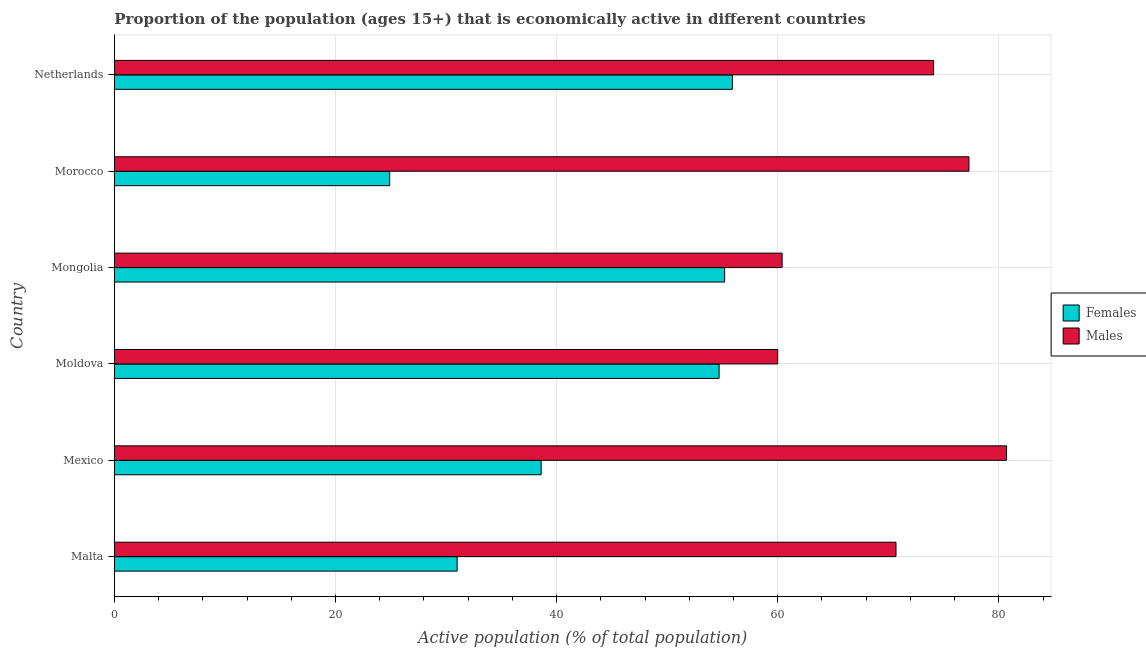How many groups of bars are there?
Your response must be concise. 6. Are the number of bars on each tick of the Y-axis equal?
Offer a very short reply. Yes. What is the label of the 2nd group of bars from the top?
Keep it short and to the point. Morocco. Across all countries, what is the maximum percentage of economically active female population?
Your response must be concise. 55.9. Across all countries, what is the minimum percentage of economically active male population?
Your answer should be compact. 60. In which country was the percentage of economically active female population minimum?
Your answer should be compact. Morocco. What is the total percentage of economically active male population in the graph?
Provide a short and direct response. 423.2. What is the difference between the percentage of economically active male population in Mongolia and that in Morocco?
Your answer should be compact. -16.9. What is the difference between the percentage of economically active male population in Mongolia and the percentage of economically active female population in Mexico?
Make the answer very short. 21.8. What is the average percentage of economically active female population per country?
Provide a short and direct response. 43.38. What is the ratio of the percentage of economically active male population in Mexico to that in Moldova?
Make the answer very short. 1.34. What is the difference between the highest and the lowest percentage of economically active male population?
Provide a succinct answer. 20.7. In how many countries, is the percentage of economically active male population greater than the average percentage of economically active male population taken over all countries?
Provide a succinct answer. 4. What does the 2nd bar from the top in Malta represents?
Give a very brief answer. Females. What does the 2nd bar from the bottom in Mongolia represents?
Give a very brief answer. Males. Are the values on the major ticks of X-axis written in scientific E-notation?
Offer a terse response. No. Does the graph contain any zero values?
Make the answer very short. No. How are the legend labels stacked?
Ensure brevity in your answer.  Vertical. What is the title of the graph?
Offer a terse response. Proportion of the population (ages 15+) that is economically active in different countries. What is the label or title of the X-axis?
Provide a short and direct response. Active population (% of total population). What is the label or title of the Y-axis?
Offer a terse response. Country. What is the Active population (% of total population) in Females in Malta?
Offer a very short reply. 31. What is the Active population (% of total population) in Males in Malta?
Make the answer very short. 70.7. What is the Active population (% of total population) in Females in Mexico?
Offer a very short reply. 38.6. What is the Active population (% of total population) in Males in Mexico?
Provide a succinct answer. 80.7. What is the Active population (% of total population) in Females in Moldova?
Provide a short and direct response. 54.7. What is the Active population (% of total population) of Males in Moldova?
Your answer should be compact. 60. What is the Active population (% of total population) of Females in Mongolia?
Offer a very short reply. 55.2. What is the Active population (% of total population) of Males in Mongolia?
Provide a succinct answer. 60.4. What is the Active population (% of total population) of Females in Morocco?
Offer a terse response. 24.9. What is the Active population (% of total population) in Males in Morocco?
Your answer should be very brief. 77.3. What is the Active population (% of total population) in Females in Netherlands?
Offer a very short reply. 55.9. What is the Active population (% of total population) of Males in Netherlands?
Your answer should be compact. 74.1. Across all countries, what is the maximum Active population (% of total population) in Females?
Give a very brief answer. 55.9. Across all countries, what is the maximum Active population (% of total population) of Males?
Your answer should be compact. 80.7. Across all countries, what is the minimum Active population (% of total population) of Females?
Keep it short and to the point. 24.9. What is the total Active population (% of total population) in Females in the graph?
Give a very brief answer. 260.3. What is the total Active population (% of total population) of Males in the graph?
Give a very brief answer. 423.2. What is the difference between the Active population (% of total population) in Females in Malta and that in Moldova?
Make the answer very short. -23.7. What is the difference between the Active population (% of total population) in Males in Malta and that in Moldova?
Your answer should be very brief. 10.7. What is the difference between the Active population (% of total population) in Females in Malta and that in Mongolia?
Make the answer very short. -24.2. What is the difference between the Active population (% of total population) of Males in Malta and that in Mongolia?
Provide a succinct answer. 10.3. What is the difference between the Active population (% of total population) in Females in Malta and that in Netherlands?
Offer a very short reply. -24.9. What is the difference between the Active population (% of total population) of Males in Malta and that in Netherlands?
Offer a terse response. -3.4. What is the difference between the Active population (% of total population) in Females in Mexico and that in Moldova?
Keep it short and to the point. -16.1. What is the difference between the Active population (% of total population) of Males in Mexico and that in Moldova?
Your answer should be compact. 20.7. What is the difference between the Active population (% of total population) of Females in Mexico and that in Mongolia?
Make the answer very short. -16.6. What is the difference between the Active population (% of total population) of Males in Mexico and that in Mongolia?
Offer a very short reply. 20.3. What is the difference between the Active population (% of total population) in Females in Mexico and that in Netherlands?
Make the answer very short. -17.3. What is the difference between the Active population (% of total population) of Males in Mexico and that in Netherlands?
Offer a terse response. 6.6. What is the difference between the Active population (% of total population) in Females in Moldova and that in Morocco?
Ensure brevity in your answer.  29.8. What is the difference between the Active population (% of total population) of Males in Moldova and that in Morocco?
Give a very brief answer. -17.3. What is the difference between the Active population (% of total population) in Males in Moldova and that in Netherlands?
Make the answer very short. -14.1. What is the difference between the Active population (% of total population) of Females in Mongolia and that in Morocco?
Ensure brevity in your answer.  30.3. What is the difference between the Active population (% of total population) in Males in Mongolia and that in Morocco?
Offer a very short reply. -16.9. What is the difference between the Active population (% of total population) of Males in Mongolia and that in Netherlands?
Provide a succinct answer. -13.7. What is the difference between the Active population (% of total population) in Females in Morocco and that in Netherlands?
Provide a succinct answer. -31. What is the difference between the Active population (% of total population) in Females in Malta and the Active population (% of total population) in Males in Mexico?
Ensure brevity in your answer.  -49.7. What is the difference between the Active population (% of total population) in Females in Malta and the Active population (% of total population) in Males in Mongolia?
Provide a short and direct response. -29.4. What is the difference between the Active population (% of total population) in Females in Malta and the Active population (% of total population) in Males in Morocco?
Make the answer very short. -46.3. What is the difference between the Active population (% of total population) of Females in Malta and the Active population (% of total population) of Males in Netherlands?
Make the answer very short. -43.1. What is the difference between the Active population (% of total population) in Females in Mexico and the Active population (% of total population) in Males in Moldova?
Provide a short and direct response. -21.4. What is the difference between the Active population (% of total population) of Females in Mexico and the Active population (% of total population) of Males in Mongolia?
Ensure brevity in your answer.  -21.8. What is the difference between the Active population (% of total population) of Females in Mexico and the Active population (% of total population) of Males in Morocco?
Offer a very short reply. -38.7. What is the difference between the Active population (% of total population) of Females in Mexico and the Active population (% of total population) of Males in Netherlands?
Your response must be concise. -35.5. What is the difference between the Active population (% of total population) in Females in Moldova and the Active population (% of total population) in Males in Mongolia?
Provide a short and direct response. -5.7. What is the difference between the Active population (% of total population) of Females in Moldova and the Active population (% of total population) of Males in Morocco?
Keep it short and to the point. -22.6. What is the difference between the Active population (% of total population) of Females in Moldova and the Active population (% of total population) of Males in Netherlands?
Offer a very short reply. -19.4. What is the difference between the Active population (% of total population) in Females in Mongolia and the Active population (% of total population) in Males in Morocco?
Provide a succinct answer. -22.1. What is the difference between the Active population (% of total population) in Females in Mongolia and the Active population (% of total population) in Males in Netherlands?
Keep it short and to the point. -18.9. What is the difference between the Active population (% of total population) of Females in Morocco and the Active population (% of total population) of Males in Netherlands?
Make the answer very short. -49.2. What is the average Active population (% of total population) of Females per country?
Your answer should be very brief. 43.38. What is the average Active population (% of total population) in Males per country?
Make the answer very short. 70.53. What is the difference between the Active population (% of total population) in Females and Active population (% of total population) in Males in Malta?
Your answer should be very brief. -39.7. What is the difference between the Active population (% of total population) of Females and Active population (% of total population) of Males in Mexico?
Make the answer very short. -42.1. What is the difference between the Active population (% of total population) in Females and Active population (% of total population) in Males in Morocco?
Keep it short and to the point. -52.4. What is the difference between the Active population (% of total population) in Females and Active population (% of total population) in Males in Netherlands?
Ensure brevity in your answer.  -18.2. What is the ratio of the Active population (% of total population) of Females in Malta to that in Mexico?
Give a very brief answer. 0.8. What is the ratio of the Active population (% of total population) of Males in Malta to that in Mexico?
Offer a very short reply. 0.88. What is the ratio of the Active population (% of total population) in Females in Malta to that in Moldova?
Your response must be concise. 0.57. What is the ratio of the Active population (% of total population) of Males in Malta to that in Moldova?
Your answer should be very brief. 1.18. What is the ratio of the Active population (% of total population) in Females in Malta to that in Mongolia?
Give a very brief answer. 0.56. What is the ratio of the Active population (% of total population) of Males in Malta to that in Mongolia?
Make the answer very short. 1.17. What is the ratio of the Active population (% of total population) in Females in Malta to that in Morocco?
Ensure brevity in your answer.  1.25. What is the ratio of the Active population (% of total population) in Males in Malta to that in Morocco?
Give a very brief answer. 0.91. What is the ratio of the Active population (% of total population) of Females in Malta to that in Netherlands?
Provide a succinct answer. 0.55. What is the ratio of the Active population (% of total population) in Males in Malta to that in Netherlands?
Keep it short and to the point. 0.95. What is the ratio of the Active population (% of total population) of Females in Mexico to that in Moldova?
Provide a succinct answer. 0.71. What is the ratio of the Active population (% of total population) of Males in Mexico to that in Moldova?
Ensure brevity in your answer.  1.34. What is the ratio of the Active population (% of total population) in Females in Mexico to that in Mongolia?
Your answer should be very brief. 0.7. What is the ratio of the Active population (% of total population) in Males in Mexico to that in Mongolia?
Keep it short and to the point. 1.34. What is the ratio of the Active population (% of total population) of Females in Mexico to that in Morocco?
Keep it short and to the point. 1.55. What is the ratio of the Active population (% of total population) in Males in Mexico to that in Morocco?
Offer a very short reply. 1.04. What is the ratio of the Active population (% of total population) of Females in Mexico to that in Netherlands?
Your answer should be compact. 0.69. What is the ratio of the Active population (% of total population) in Males in Mexico to that in Netherlands?
Make the answer very short. 1.09. What is the ratio of the Active population (% of total population) in Females in Moldova to that in Mongolia?
Make the answer very short. 0.99. What is the ratio of the Active population (% of total population) of Females in Moldova to that in Morocco?
Offer a very short reply. 2.2. What is the ratio of the Active population (% of total population) of Males in Moldova to that in Morocco?
Give a very brief answer. 0.78. What is the ratio of the Active population (% of total population) of Females in Moldova to that in Netherlands?
Your answer should be compact. 0.98. What is the ratio of the Active population (% of total population) in Males in Moldova to that in Netherlands?
Ensure brevity in your answer.  0.81. What is the ratio of the Active population (% of total population) of Females in Mongolia to that in Morocco?
Ensure brevity in your answer.  2.22. What is the ratio of the Active population (% of total population) in Males in Mongolia to that in Morocco?
Provide a succinct answer. 0.78. What is the ratio of the Active population (% of total population) of Females in Mongolia to that in Netherlands?
Give a very brief answer. 0.99. What is the ratio of the Active population (% of total population) in Males in Mongolia to that in Netherlands?
Your answer should be very brief. 0.82. What is the ratio of the Active population (% of total population) in Females in Morocco to that in Netherlands?
Your answer should be very brief. 0.45. What is the ratio of the Active population (% of total population) in Males in Morocco to that in Netherlands?
Keep it short and to the point. 1.04. What is the difference between the highest and the second highest Active population (% of total population) in Males?
Your answer should be very brief. 3.4. What is the difference between the highest and the lowest Active population (% of total population) in Females?
Your answer should be compact. 31. What is the difference between the highest and the lowest Active population (% of total population) of Males?
Make the answer very short. 20.7. 